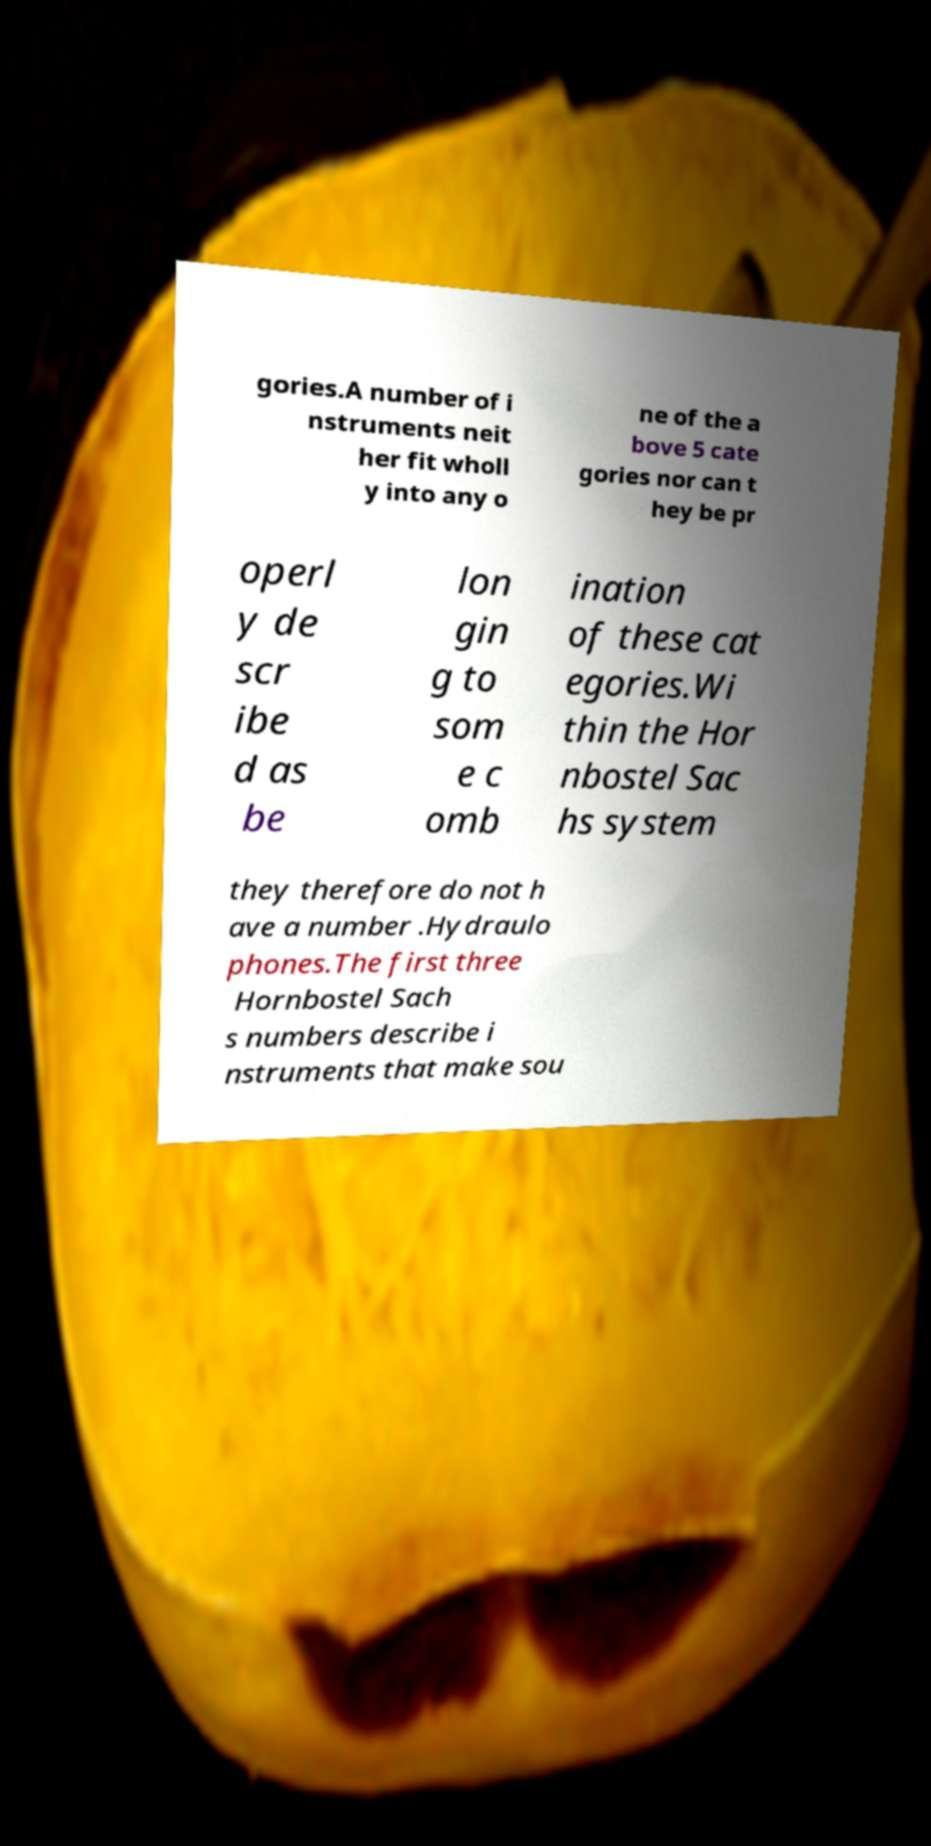For documentation purposes, I need the text within this image transcribed. Could you provide that? gories.A number of i nstruments neit her fit wholl y into any o ne of the a bove 5 cate gories nor can t hey be pr operl y de scr ibe d as be lon gin g to som e c omb ination of these cat egories.Wi thin the Hor nbostel Sac hs system they therefore do not h ave a number .Hydraulo phones.The first three Hornbostel Sach s numbers describe i nstruments that make sou 